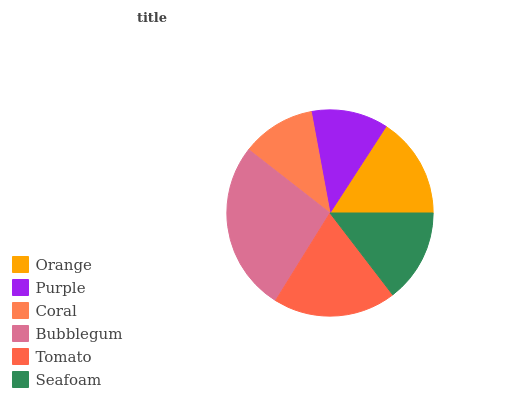Is Coral the minimum?
Answer yes or no. Yes. Is Bubblegum the maximum?
Answer yes or no. Yes. Is Purple the minimum?
Answer yes or no. No. Is Purple the maximum?
Answer yes or no. No. Is Orange greater than Purple?
Answer yes or no. Yes. Is Purple less than Orange?
Answer yes or no. Yes. Is Purple greater than Orange?
Answer yes or no. No. Is Orange less than Purple?
Answer yes or no. No. Is Orange the high median?
Answer yes or no. Yes. Is Seafoam the low median?
Answer yes or no. Yes. Is Tomato the high median?
Answer yes or no. No. Is Bubblegum the low median?
Answer yes or no. No. 